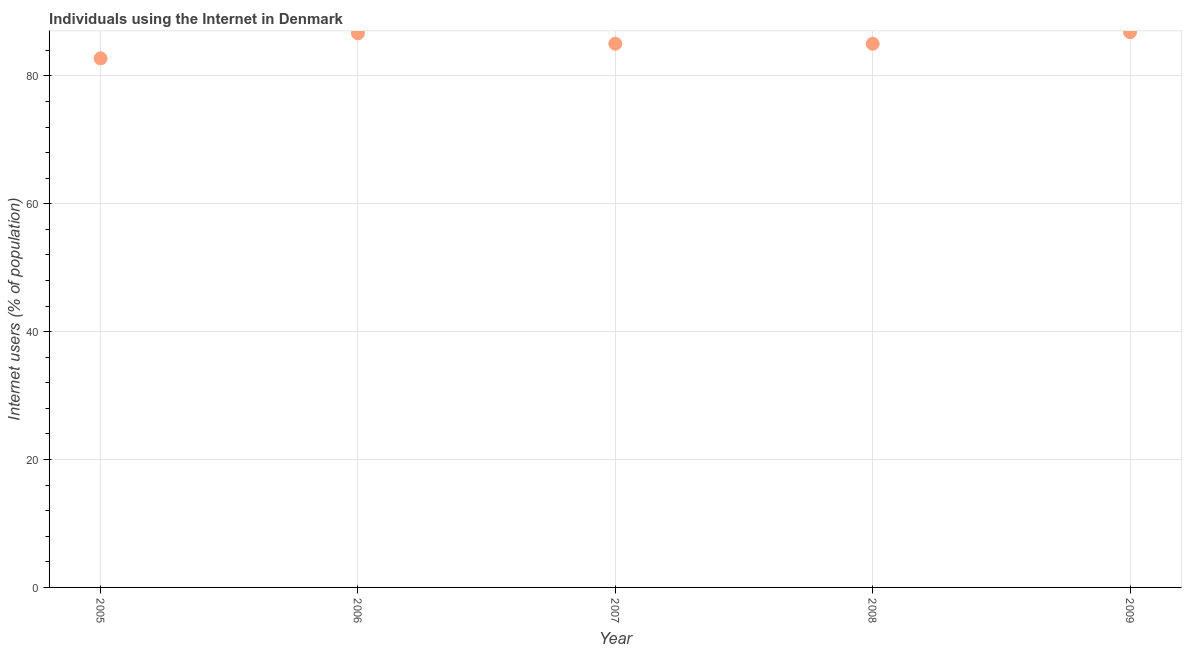What is the number of internet users in 2008?
Give a very brief answer. 85.02. Across all years, what is the maximum number of internet users?
Offer a very short reply. 86.84. Across all years, what is the minimum number of internet users?
Your response must be concise. 82.74. In which year was the number of internet users maximum?
Provide a short and direct response. 2009. In which year was the number of internet users minimum?
Give a very brief answer. 2005. What is the sum of the number of internet users?
Ensure brevity in your answer.  426.28. What is the difference between the number of internet users in 2006 and 2008?
Make the answer very short. 1.63. What is the average number of internet users per year?
Provide a short and direct response. 85.26. What is the median number of internet users?
Make the answer very short. 85.03. In how many years, is the number of internet users greater than 12 %?
Make the answer very short. 5. What is the ratio of the number of internet users in 2008 to that in 2009?
Keep it short and to the point. 0.98. What is the difference between the highest and the second highest number of internet users?
Offer a very short reply. 0.19. What is the difference between the highest and the lowest number of internet users?
Your answer should be very brief. 4.1. Does the number of internet users monotonically increase over the years?
Provide a short and direct response. No. How many dotlines are there?
Offer a terse response. 1. What is the difference between two consecutive major ticks on the Y-axis?
Keep it short and to the point. 20. What is the title of the graph?
Make the answer very short. Individuals using the Internet in Denmark. What is the label or title of the Y-axis?
Provide a short and direct response. Internet users (% of population). What is the Internet users (% of population) in 2005?
Provide a short and direct response. 82.74. What is the Internet users (% of population) in 2006?
Provide a succinct answer. 86.65. What is the Internet users (% of population) in 2007?
Ensure brevity in your answer.  85.03. What is the Internet users (% of population) in 2008?
Provide a succinct answer. 85.02. What is the Internet users (% of population) in 2009?
Provide a succinct answer. 86.84. What is the difference between the Internet users (% of population) in 2005 and 2006?
Provide a short and direct response. -3.91. What is the difference between the Internet users (% of population) in 2005 and 2007?
Offer a terse response. -2.29. What is the difference between the Internet users (% of population) in 2005 and 2008?
Ensure brevity in your answer.  -2.28. What is the difference between the Internet users (% of population) in 2005 and 2009?
Ensure brevity in your answer.  -4.1. What is the difference between the Internet users (% of population) in 2006 and 2007?
Give a very brief answer. 1.62. What is the difference between the Internet users (% of population) in 2006 and 2008?
Provide a short and direct response. 1.63. What is the difference between the Internet users (% of population) in 2006 and 2009?
Offer a terse response. -0.19. What is the difference between the Internet users (% of population) in 2007 and 2009?
Your answer should be very brief. -1.81. What is the difference between the Internet users (% of population) in 2008 and 2009?
Provide a succinct answer. -1.82. What is the ratio of the Internet users (% of population) in 2005 to that in 2006?
Your answer should be very brief. 0.95. What is the ratio of the Internet users (% of population) in 2005 to that in 2008?
Give a very brief answer. 0.97. What is the ratio of the Internet users (% of population) in 2005 to that in 2009?
Ensure brevity in your answer.  0.95. What is the ratio of the Internet users (% of population) in 2006 to that in 2007?
Provide a succinct answer. 1.02. What is the ratio of the Internet users (% of population) in 2007 to that in 2008?
Your answer should be very brief. 1. What is the ratio of the Internet users (% of population) in 2007 to that in 2009?
Provide a short and direct response. 0.98. What is the ratio of the Internet users (% of population) in 2008 to that in 2009?
Keep it short and to the point. 0.98. 